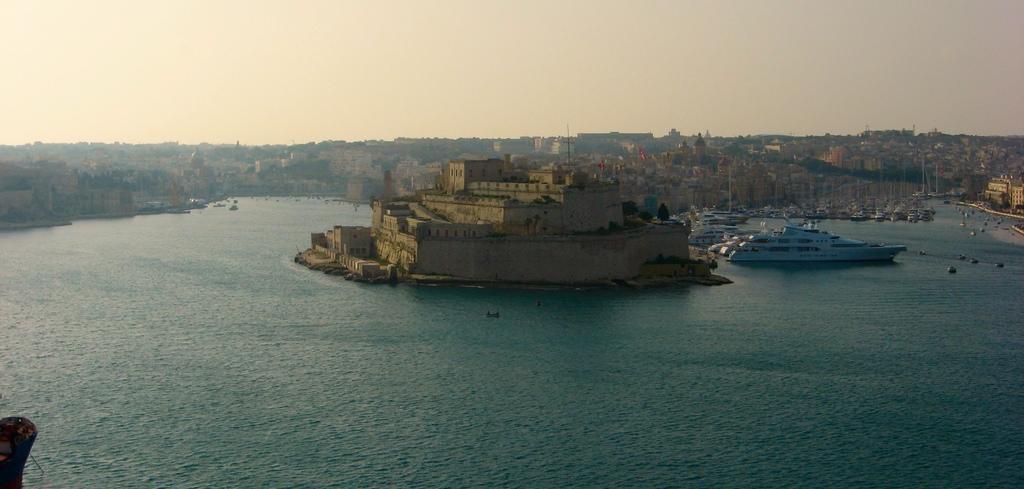Could you give a brief overview of what you see in this image? In this image we can see water, ships floating on the water, stone building, a few more buildings and the sky in the background. 